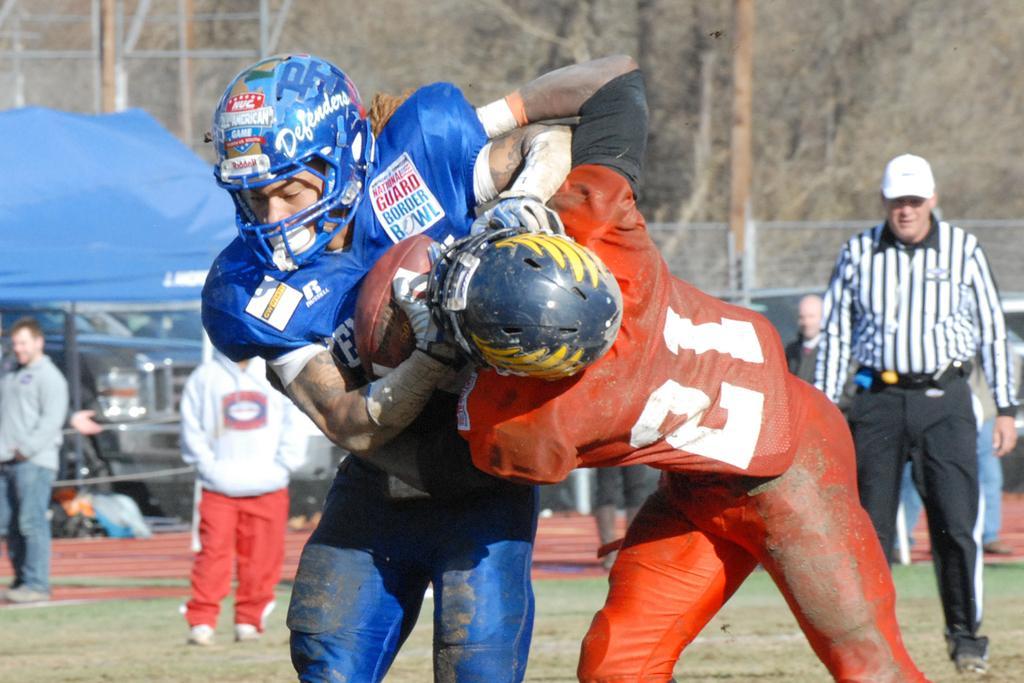Could you give a brief overview of what you see in this image? In this picture we can see a group of people on the ground and in the background we can see a fence,trees. 